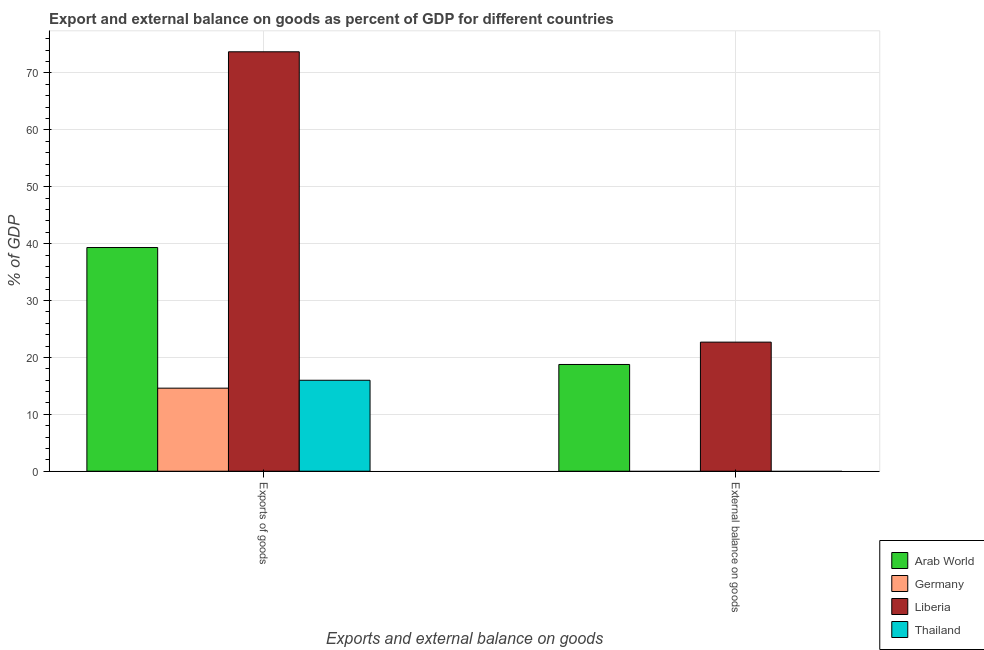What is the label of the 1st group of bars from the left?
Keep it short and to the point. Exports of goods. What is the external balance on goods as percentage of gdp in Liberia?
Make the answer very short. 22.69. Across all countries, what is the maximum external balance on goods as percentage of gdp?
Your answer should be very brief. 22.69. In which country was the export of goods as percentage of gdp maximum?
Provide a short and direct response. Liberia. What is the total external balance on goods as percentage of gdp in the graph?
Your answer should be very brief. 41.45. What is the difference between the export of goods as percentage of gdp in Liberia and that in Thailand?
Keep it short and to the point. 57.74. What is the difference between the external balance on goods as percentage of gdp in Germany and the export of goods as percentage of gdp in Arab World?
Your answer should be compact. -39.32. What is the average external balance on goods as percentage of gdp per country?
Make the answer very short. 10.36. What is the difference between the export of goods as percentage of gdp and external balance on goods as percentage of gdp in Liberia?
Offer a very short reply. 51.03. In how many countries, is the external balance on goods as percentage of gdp greater than 10 %?
Your answer should be very brief. 2. What is the ratio of the export of goods as percentage of gdp in Liberia to that in Thailand?
Offer a terse response. 4.61. Are all the bars in the graph horizontal?
Offer a terse response. No. Does the graph contain grids?
Give a very brief answer. Yes. Where does the legend appear in the graph?
Your answer should be compact. Bottom right. How many legend labels are there?
Make the answer very short. 4. How are the legend labels stacked?
Keep it short and to the point. Vertical. What is the title of the graph?
Your answer should be very brief. Export and external balance on goods as percent of GDP for different countries. Does "Gabon" appear as one of the legend labels in the graph?
Give a very brief answer. No. What is the label or title of the X-axis?
Provide a short and direct response. Exports and external balance on goods. What is the label or title of the Y-axis?
Offer a very short reply. % of GDP. What is the % of GDP in Arab World in Exports of goods?
Give a very brief answer. 39.32. What is the % of GDP of Germany in Exports of goods?
Offer a very short reply. 14.6. What is the % of GDP of Liberia in Exports of goods?
Provide a short and direct response. 73.72. What is the % of GDP in Thailand in Exports of goods?
Your answer should be compact. 15.99. What is the % of GDP of Arab World in External balance on goods?
Provide a succinct answer. 18.76. What is the % of GDP in Liberia in External balance on goods?
Your answer should be compact. 22.69. Across all Exports and external balance on goods, what is the maximum % of GDP in Arab World?
Ensure brevity in your answer.  39.32. Across all Exports and external balance on goods, what is the maximum % of GDP of Germany?
Give a very brief answer. 14.6. Across all Exports and external balance on goods, what is the maximum % of GDP of Liberia?
Offer a very short reply. 73.72. Across all Exports and external balance on goods, what is the maximum % of GDP in Thailand?
Keep it short and to the point. 15.99. Across all Exports and external balance on goods, what is the minimum % of GDP of Arab World?
Your response must be concise. 18.76. Across all Exports and external balance on goods, what is the minimum % of GDP of Germany?
Provide a short and direct response. 0. Across all Exports and external balance on goods, what is the minimum % of GDP of Liberia?
Give a very brief answer. 22.69. Across all Exports and external balance on goods, what is the minimum % of GDP in Thailand?
Ensure brevity in your answer.  0. What is the total % of GDP of Arab World in the graph?
Offer a very short reply. 58.08. What is the total % of GDP of Germany in the graph?
Give a very brief answer. 14.6. What is the total % of GDP of Liberia in the graph?
Keep it short and to the point. 96.42. What is the total % of GDP in Thailand in the graph?
Offer a very short reply. 15.99. What is the difference between the % of GDP of Arab World in Exports of goods and that in External balance on goods?
Give a very brief answer. 20.56. What is the difference between the % of GDP of Liberia in Exports of goods and that in External balance on goods?
Give a very brief answer. 51.03. What is the difference between the % of GDP of Arab World in Exports of goods and the % of GDP of Liberia in External balance on goods?
Ensure brevity in your answer.  16.63. What is the difference between the % of GDP of Germany in Exports of goods and the % of GDP of Liberia in External balance on goods?
Provide a short and direct response. -8.09. What is the average % of GDP in Arab World per Exports and external balance on goods?
Make the answer very short. 29.04. What is the average % of GDP of Germany per Exports and external balance on goods?
Make the answer very short. 7.3. What is the average % of GDP of Liberia per Exports and external balance on goods?
Offer a terse response. 48.21. What is the average % of GDP of Thailand per Exports and external balance on goods?
Offer a terse response. 7.99. What is the difference between the % of GDP in Arab World and % of GDP in Germany in Exports of goods?
Provide a short and direct response. 24.72. What is the difference between the % of GDP of Arab World and % of GDP of Liberia in Exports of goods?
Offer a terse response. -34.41. What is the difference between the % of GDP of Arab World and % of GDP of Thailand in Exports of goods?
Keep it short and to the point. 23.33. What is the difference between the % of GDP in Germany and % of GDP in Liberia in Exports of goods?
Ensure brevity in your answer.  -59.12. What is the difference between the % of GDP of Germany and % of GDP of Thailand in Exports of goods?
Your answer should be very brief. -1.39. What is the difference between the % of GDP in Liberia and % of GDP in Thailand in Exports of goods?
Your response must be concise. 57.74. What is the difference between the % of GDP of Arab World and % of GDP of Liberia in External balance on goods?
Provide a succinct answer. -3.93. What is the ratio of the % of GDP in Arab World in Exports of goods to that in External balance on goods?
Ensure brevity in your answer.  2.1. What is the ratio of the % of GDP in Liberia in Exports of goods to that in External balance on goods?
Provide a short and direct response. 3.25. What is the difference between the highest and the second highest % of GDP of Arab World?
Give a very brief answer. 20.56. What is the difference between the highest and the second highest % of GDP in Liberia?
Offer a terse response. 51.03. What is the difference between the highest and the lowest % of GDP in Arab World?
Keep it short and to the point. 20.56. What is the difference between the highest and the lowest % of GDP of Germany?
Provide a succinct answer. 14.6. What is the difference between the highest and the lowest % of GDP of Liberia?
Ensure brevity in your answer.  51.03. What is the difference between the highest and the lowest % of GDP in Thailand?
Make the answer very short. 15.99. 